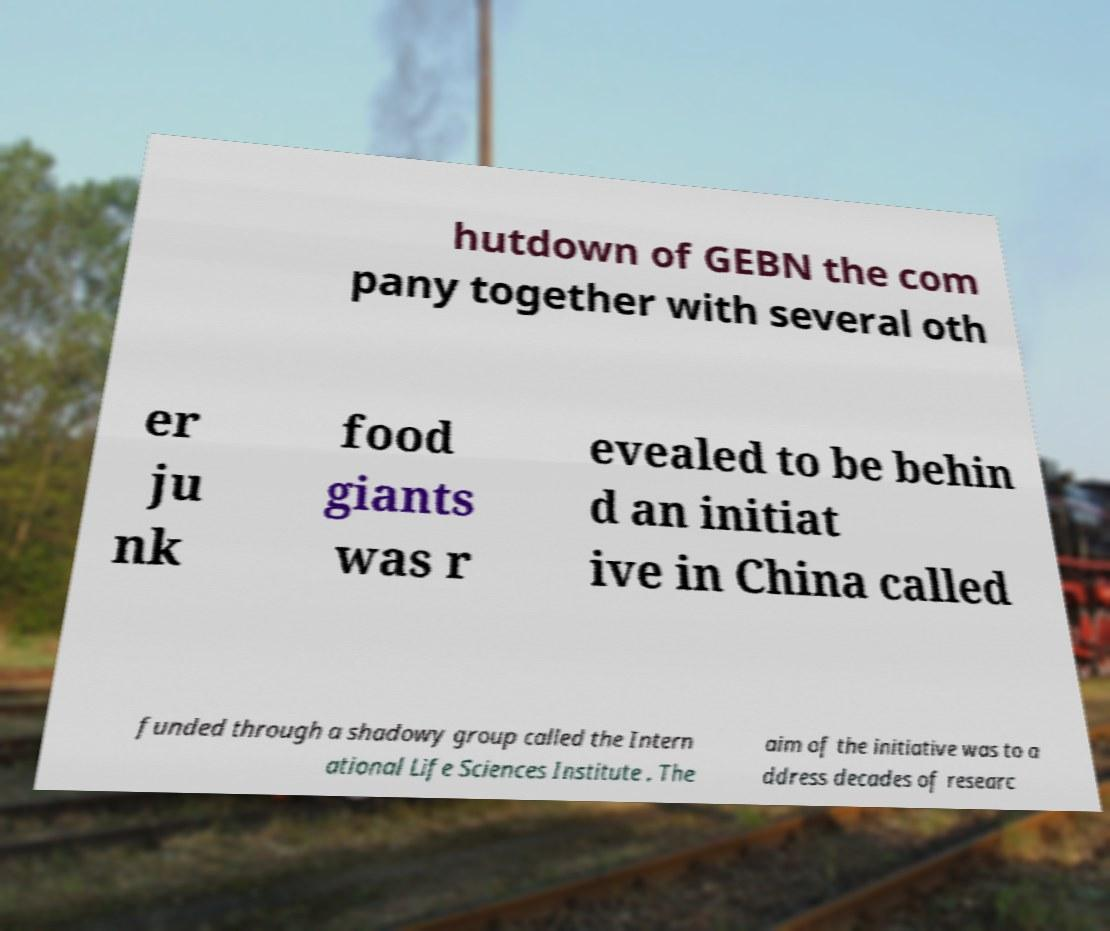What messages or text are displayed in this image? I need them in a readable, typed format. hutdown of GEBN the com pany together with several oth er ju nk food giants was r evealed to be behin d an initiat ive in China called funded through a shadowy group called the Intern ational Life Sciences Institute . The aim of the initiative was to a ddress decades of researc 